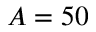Convert formula to latex. <formula><loc_0><loc_0><loc_500><loc_500>A = 5 0</formula> 